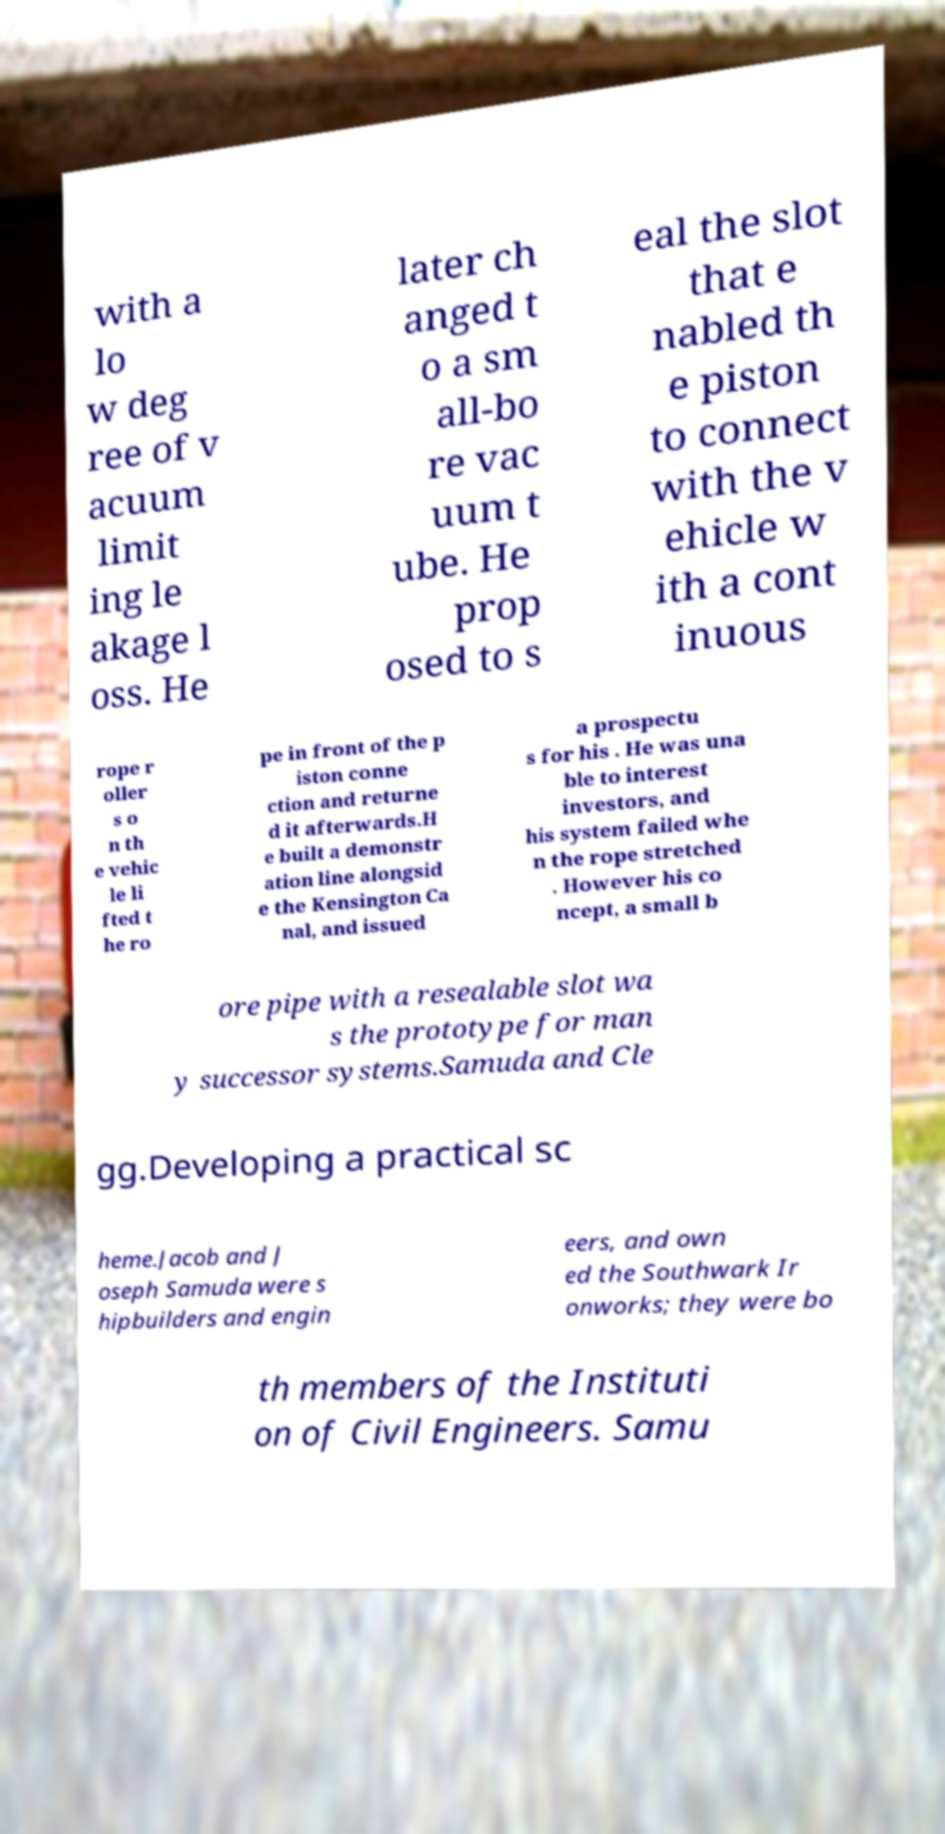What messages or text are displayed in this image? I need them in a readable, typed format. with a lo w deg ree of v acuum limit ing le akage l oss. He later ch anged t o a sm all-bo re vac uum t ube. He prop osed to s eal the slot that e nabled th e piston to connect with the v ehicle w ith a cont inuous rope r oller s o n th e vehic le li fted t he ro pe in front of the p iston conne ction and returne d it afterwards.H e built a demonstr ation line alongsid e the Kensington Ca nal, and issued a prospectu s for his . He was una ble to interest investors, and his system failed whe n the rope stretched . However his co ncept, a small b ore pipe with a resealable slot wa s the prototype for man y successor systems.Samuda and Cle gg.Developing a practical sc heme.Jacob and J oseph Samuda were s hipbuilders and engin eers, and own ed the Southwark Ir onworks; they were bo th members of the Instituti on of Civil Engineers. Samu 